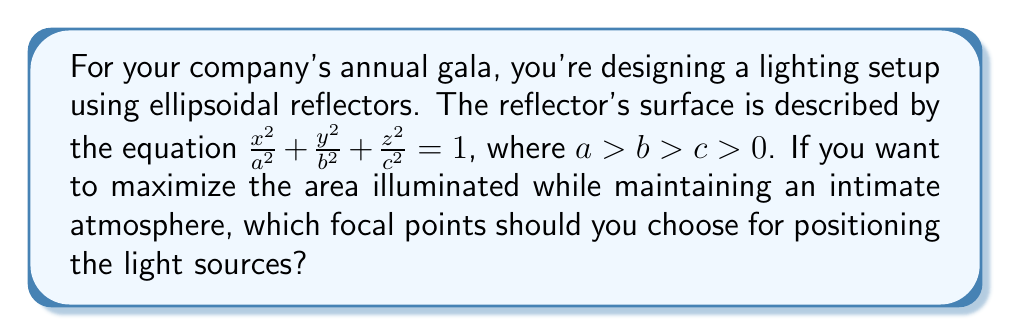Solve this math problem. To solve this problem, we'll follow these steps:

1) An ellipsoid has two focal points. For an ellipsoid with equation $\frac{x^2}{a^2} + \frac{y^2}{b^2} + \frac{z^2}{c^2} = 1$, the focal points are located at $(±\sqrt{a^2-c^2}, 0, 0)$.

2) The property of an ellipsoidal reflector is that light rays emanating from one focal point will be reflected to pass through the other focal point.

3) To maximize the illuminated area while maintaining an intimate atmosphere, we want to choose the focal points that are furthest apart. This will create a wider spread of light.

4) The distance between the focal points is $2\sqrt{a^2-c^2}$.

5) Given $a > b > c > 0$, the largest possible distance between focal points will be achieved when we use the largest semi-axis $a$ and the smallest semi-axis $c$.

6) Therefore, the optimal focal points for positioning the light sources are $(±\sqrt{a^2-c^2}, 0, 0)$.

[asy]
import three;
size(200);
currentprojection=perspective(6,3,2);

real a=2, b=1.5, c=1;
real f=sqrt(a^2-c^2);

draw(surface(ellipsoid(a,b,c)),white);
draw((f,0,0)--(0,0,0)--(-f,0,0),red);
dot((f,0,0),red);
dot((-f,0,0),red);
label("F1",(f,0,0),E);
label("F2",(-f,0,0),W);
[/asy]
Answer: $(±\sqrt{a^2-c^2}, 0, 0)$ 